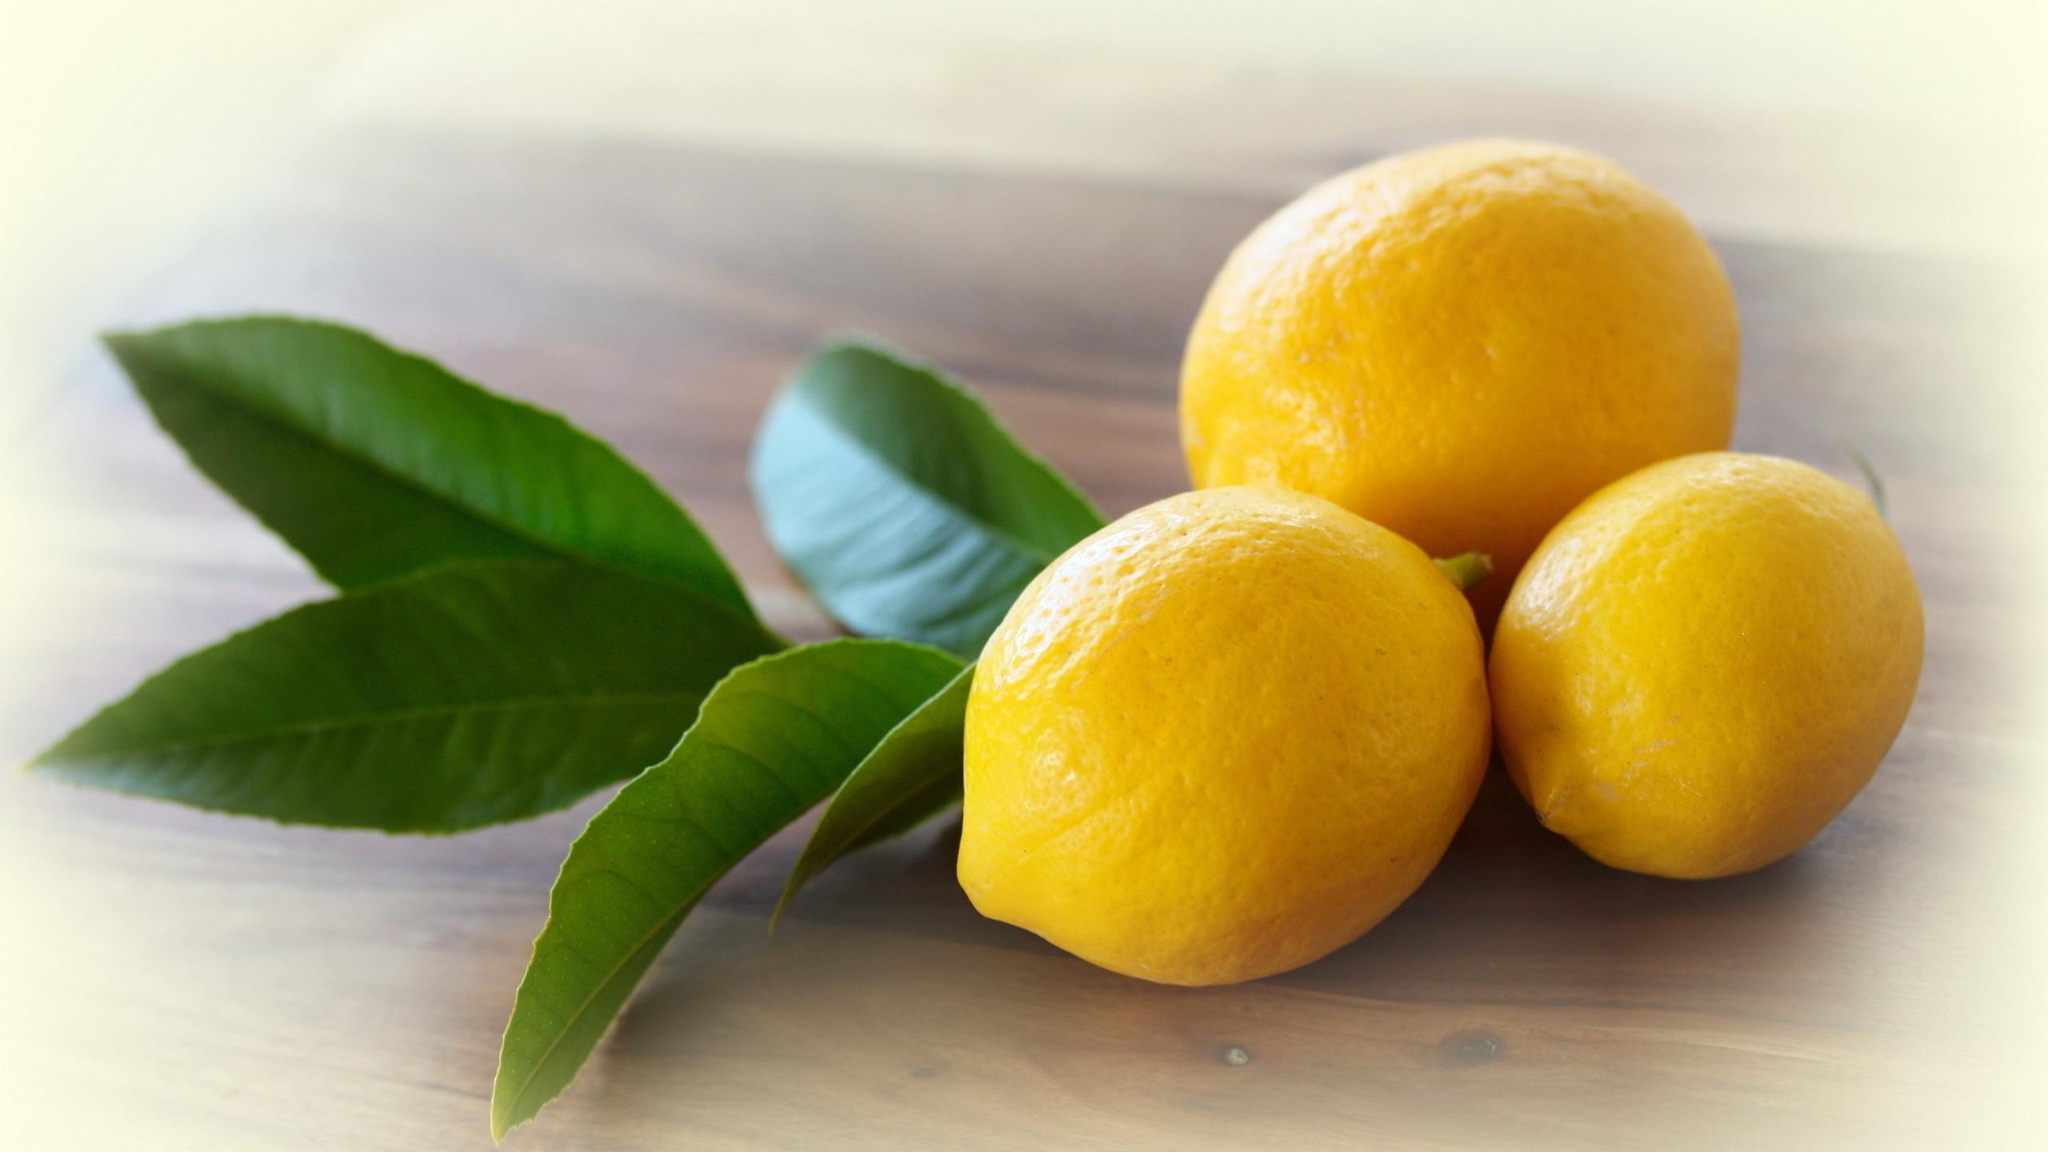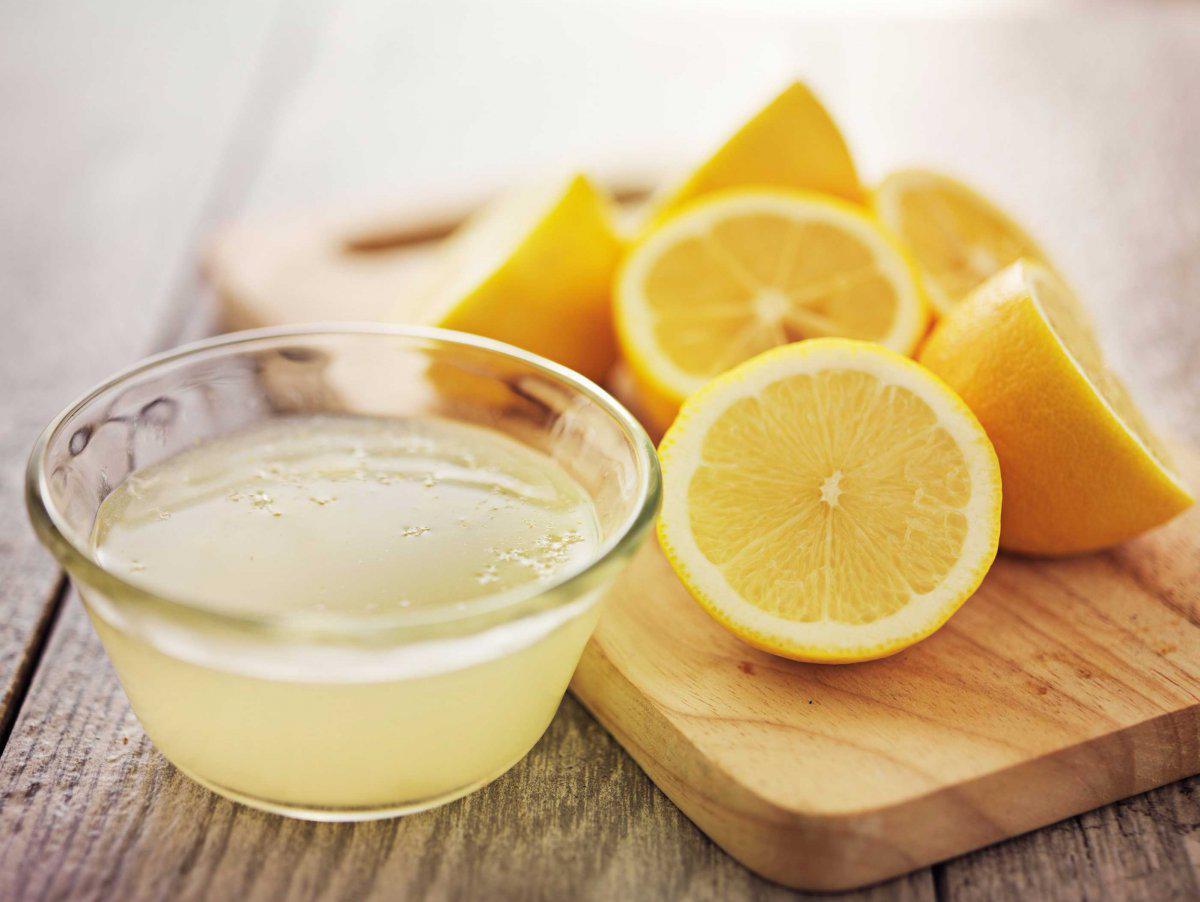The first image is the image on the left, the second image is the image on the right. Examine the images to the left and right. Is the description "There are exactly three uncut lemons." accurate? Answer yes or no. Yes. The first image is the image on the left, the second image is the image on the right. Evaluate the accuracy of this statement regarding the images: "Each image contains green leaves, lemon half, and whole lemon.". Is it true? Answer yes or no. No. 